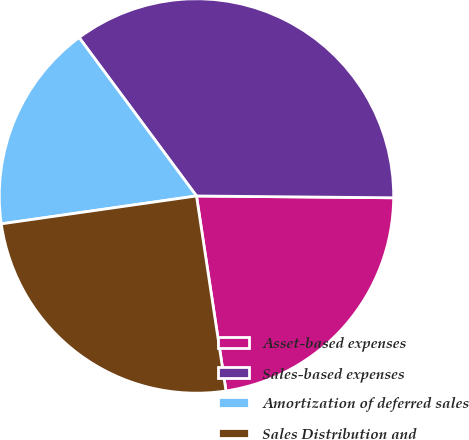Convert chart. <chart><loc_0><loc_0><loc_500><loc_500><pie_chart><fcel>Asset-based expenses<fcel>Sales-based expenses<fcel>Amortization of deferred sales<fcel>Sales Distribution and<nl><fcel>22.46%<fcel>35.29%<fcel>17.11%<fcel>25.13%<nl></chart> 